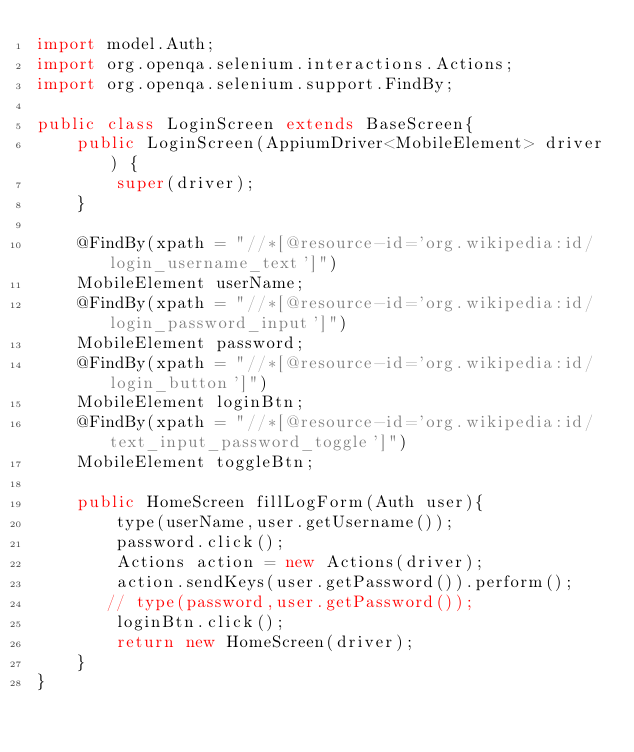Convert code to text. <code><loc_0><loc_0><loc_500><loc_500><_Java_>import model.Auth;
import org.openqa.selenium.interactions.Actions;
import org.openqa.selenium.support.FindBy;

public class LoginScreen extends BaseScreen{
    public LoginScreen(AppiumDriver<MobileElement> driver) {
        super(driver);
    }

    @FindBy(xpath = "//*[@resource-id='org.wikipedia:id/login_username_text']")
    MobileElement userName;
    @FindBy(xpath = "//*[@resource-id='org.wikipedia:id/login_password_input']")
    MobileElement password;
    @FindBy(xpath = "//*[@resource-id='org.wikipedia:id/login_button']")
    MobileElement loginBtn;
    @FindBy(xpath = "//*[@resource-id='org.wikipedia:id/text_input_password_toggle']")
    MobileElement toggleBtn;

    public HomeScreen fillLogForm(Auth user){
        type(userName,user.getUsername());
        password.click();
        Actions action = new Actions(driver);
        action.sendKeys(user.getPassword()).perform();
       // type(password,user.getPassword());
        loginBtn.click();
        return new HomeScreen(driver);
    }
}
</code> 